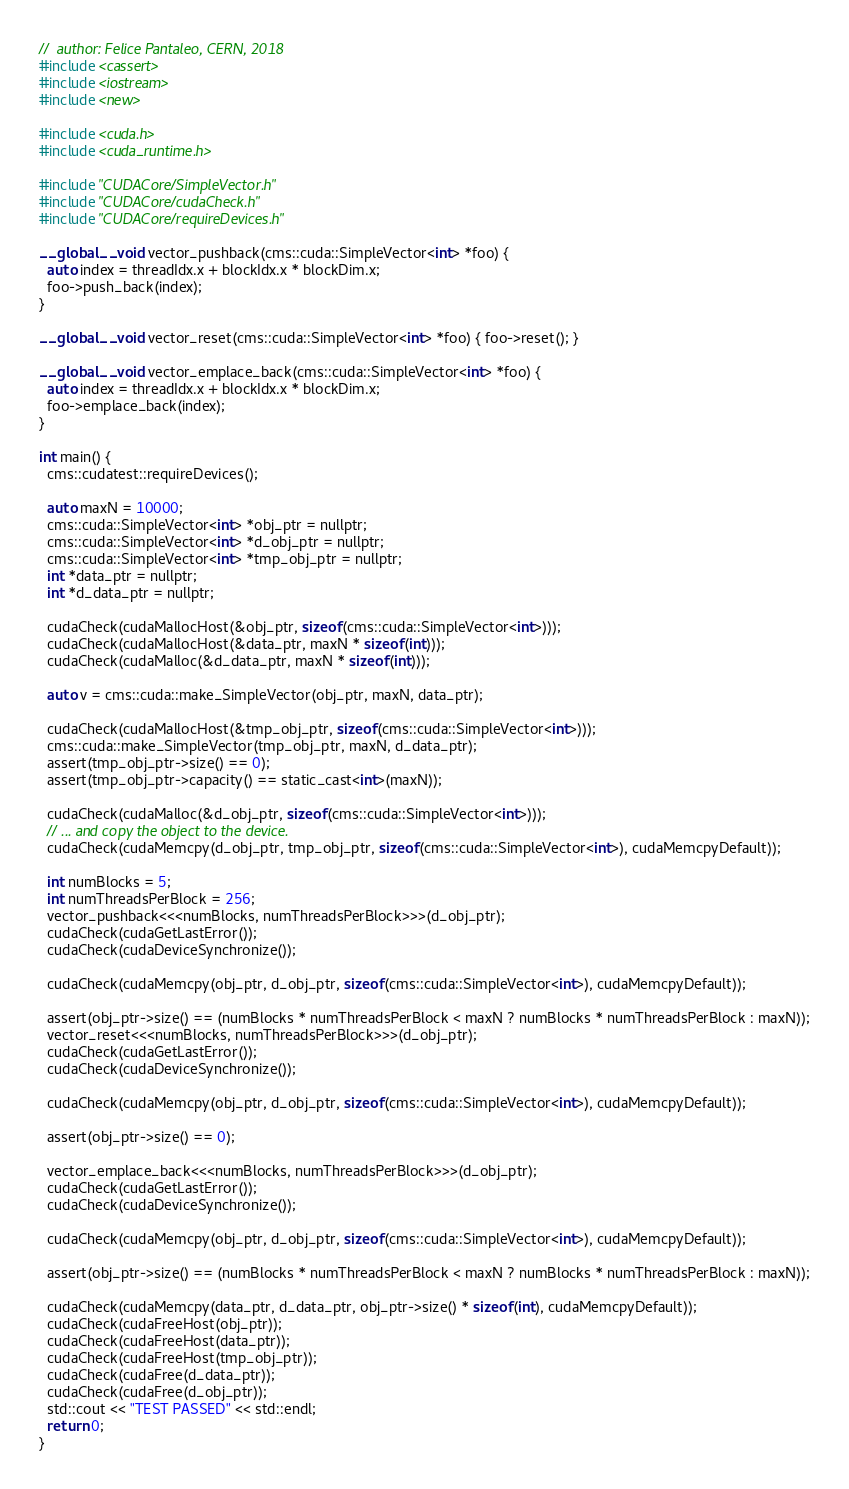Convert code to text. <code><loc_0><loc_0><loc_500><loc_500><_Cuda_>//  author: Felice Pantaleo, CERN, 2018
#include <cassert>
#include <iostream>
#include <new>

#include <cuda.h>
#include <cuda_runtime.h>

#include "CUDACore/SimpleVector.h"
#include "CUDACore/cudaCheck.h"
#include "CUDACore/requireDevices.h"

__global__ void vector_pushback(cms::cuda::SimpleVector<int> *foo) {
  auto index = threadIdx.x + blockIdx.x * blockDim.x;
  foo->push_back(index);
}

__global__ void vector_reset(cms::cuda::SimpleVector<int> *foo) { foo->reset(); }

__global__ void vector_emplace_back(cms::cuda::SimpleVector<int> *foo) {
  auto index = threadIdx.x + blockIdx.x * blockDim.x;
  foo->emplace_back(index);
}

int main() {
  cms::cudatest::requireDevices();

  auto maxN = 10000;
  cms::cuda::SimpleVector<int> *obj_ptr = nullptr;
  cms::cuda::SimpleVector<int> *d_obj_ptr = nullptr;
  cms::cuda::SimpleVector<int> *tmp_obj_ptr = nullptr;
  int *data_ptr = nullptr;
  int *d_data_ptr = nullptr;

  cudaCheck(cudaMallocHost(&obj_ptr, sizeof(cms::cuda::SimpleVector<int>)));
  cudaCheck(cudaMallocHost(&data_ptr, maxN * sizeof(int)));
  cudaCheck(cudaMalloc(&d_data_ptr, maxN * sizeof(int)));

  auto v = cms::cuda::make_SimpleVector(obj_ptr, maxN, data_ptr);

  cudaCheck(cudaMallocHost(&tmp_obj_ptr, sizeof(cms::cuda::SimpleVector<int>)));
  cms::cuda::make_SimpleVector(tmp_obj_ptr, maxN, d_data_ptr);
  assert(tmp_obj_ptr->size() == 0);
  assert(tmp_obj_ptr->capacity() == static_cast<int>(maxN));

  cudaCheck(cudaMalloc(&d_obj_ptr, sizeof(cms::cuda::SimpleVector<int>)));
  // ... and copy the object to the device.
  cudaCheck(cudaMemcpy(d_obj_ptr, tmp_obj_ptr, sizeof(cms::cuda::SimpleVector<int>), cudaMemcpyDefault));

  int numBlocks = 5;
  int numThreadsPerBlock = 256;
  vector_pushback<<<numBlocks, numThreadsPerBlock>>>(d_obj_ptr);
  cudaCheck(cudaGetLastError());
  cudaCheck(cudaDeviceSynchronize());

  cudaCheck(cudaMemcpy(obj_ptr, d_obj_ptr, sizeof(cms::cuda::SimpleVector<int>), cudaMemcpyDefault));

  assert(obj_ptr->size() == (numBlocks * numThreadsPerBlock < maxN ? numBlocks * numThreadsPerBlock : maxN));
  vector_reset<<<numBlocks, numThreadsPerBlock>>>(d_obj_ptr);
  cudaCheck(cudaGetLastError());
  cudaCheck(cudaDeviceSynchronize());

  cudaCheck(cudaMemcpy(obj_ptr, d_obj_ptr, sizeof(cms::cuda::SimpleVector<int>), cudaMemcpyDefault));

  assert(obj_ptr->size() == 0);

  vector_emplace_back<<<numBlocks, numThreadsPerBlock>>>(d_obj_ptr);
  cudaCheck(cudaGetLastError());
  cudaCheck(cudaDeviceSynchronize());

  cudaCheck(cudaMemcpy(obj_ptr, d_obj_ptr, sizeof(cms::cuda::SimpleVector<int>), cudaMemcpyDefault));

  assert(obj_ptr->size() == (numBlocks * numThreadsPerBlock < maxN ? numBlocks * numThreadsPerBlock : maxN));

  cudaCheck(cudaMemcpy(data_ptr, d_data_ptr, obj_ptr->size() * sizeof(int), cudaMemcpyDefault));
  cudaCheck(cudaFreeHost(obj_ptr));
  cudaCheck(cudaFreeHost(data_ptr));
  cudaCheck(cudaFreeHost(tmp_obj_ptr));
  cudaCheck(cudaFree(d_data_ptr));
  cudaCheck(cudaFree(d_obj_ptr));
  std::cout << "TEST PASSED" << std::endl;
  return 0;
}
</code> 